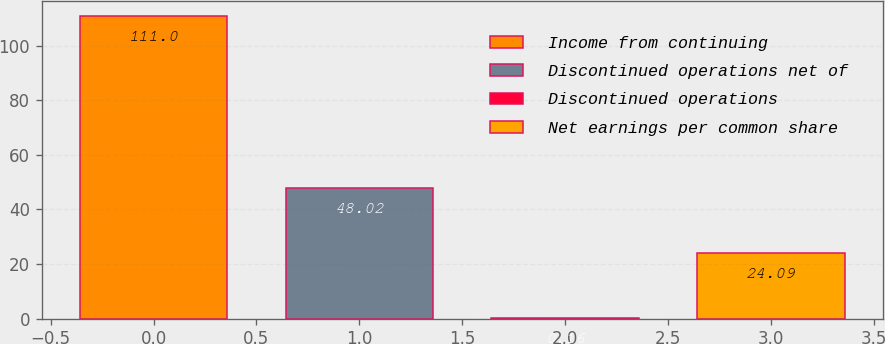<chart> <loc_0><loc_0><loc_500><loc_500><bar_chart><fcel>Income from continuing<fcel>Discontinued operations net of<fcel>Discontinued operations<fcel>Net earnings per common share<nl><fcel>111<fcel>48.02<fcel>0.16<fcel>24.09<nl></chart> 